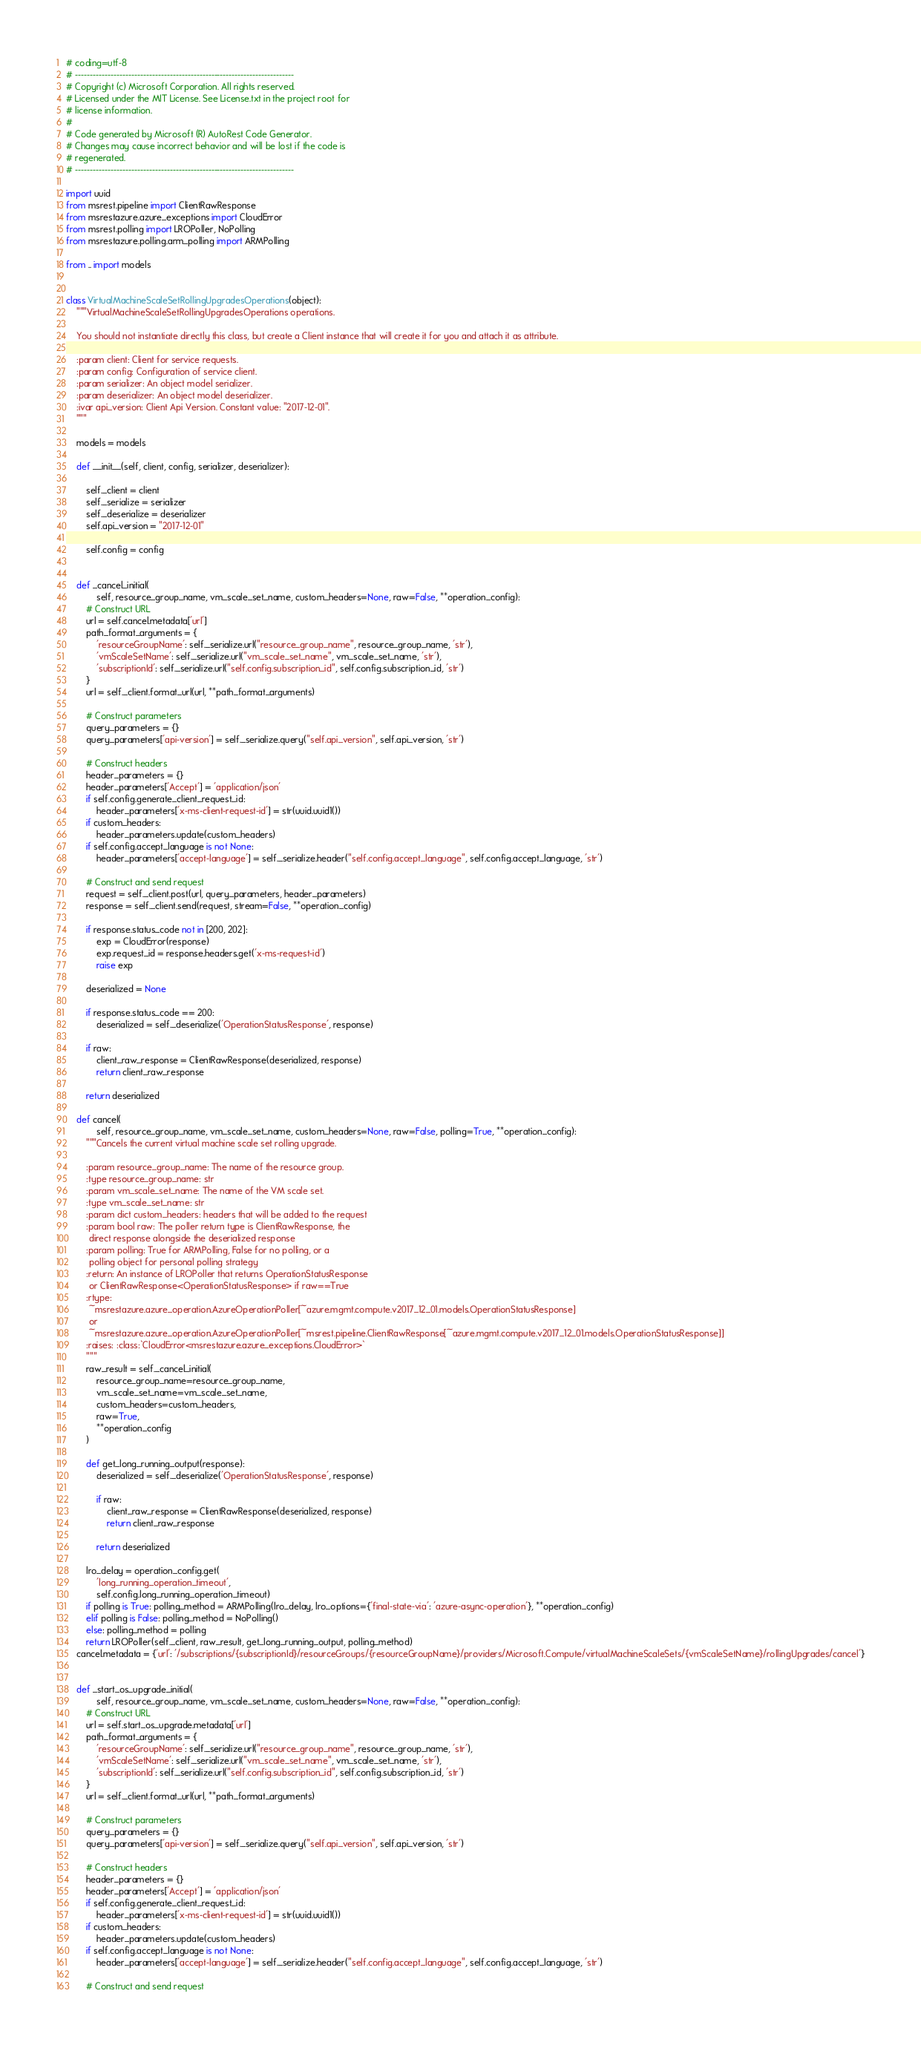<code> <loc_0><loc_0><loc_500><loc_500><_Python_># coding=utf-8
# --------------------------------------------------------------------------
# Copyright (c) Microsoft Corporation. All rights reserved.
# Licensed under the MIT License. See License.txt in the project root for
# license information.
#
# Code generated by Microsoft (R) AutoRest Code Generator.
# Changes may cause incorrect behavior and will be lost if the code is
# regenerated.
# --------------------------------------------------------------------------

import uuid
from msrest.pipeline import ClientRawResponse
from msrestazure.azure_exceptions import CloudError
from msrest.polling import LROPoller, NoPolling
from msrestazure.polling.arm_polling import ARMPolling

from .. import models


class VirtualMachineScaleSetRollingUpgradesOperations(object):
    """VirtualMachineScaleSetRollingUpgradesOperations operations.

    You should not instantiate directly this class, but create a Client instance that will create it for you and attach it as attribute.

    :param client: Client for service requests.
    :param config: Configuration of service client.
    :param serializer: An object model serializer.
    :param deserializer: An object model deserializer.
    :ivar api_version: Client Api Version. Constant value: "2017-12-01".
    """

    models = models

    def __init__(self, client, config, serializer, deserializer):

        self._client = client
        self._serialize = serializer
        self._deserialize = deserializer
        self.api_version = "2017-12-01"

        self.config = config


    def _cancel_initial(
            self, resource_group_name, vm_scale_set_name, custom_headers=None, raw=False, **operation_config):
        # Construct URL
        url = self.cancel.metadata['url']
        path_format_arguments = {
            'resourceGroupName': self._serialize.url("resource_group_name", resource_group_name, 'str'),
            'vmScaleSetName': self._serialize.url("vm_scale_set_name", vm_scale_set_name, 'str'),
            'subscriptionId': self._serialize.url("self.config.subscription_id", self.config.subscription_id, 'str')
        }
        url = self._client.format_url(url, **path_format_arguments)

        # Construct parameters
        query_parameters = {}
        query_parameters['api-version'] = self._serialize.query("self.api_version", self.api_version, 'str')

        # Construct headers
        header_parameters = {}
        header_parameters['Accept'] = 'application/json'
        if self.config.generate_client_request_id:
            header_parameters['x-ms-client-request-id'] = str(uuid.uuid1())
        if custom_headers:
            header_parameters.update(custom_headers)
        if self.config.accept_language is not None:
            header_parameters['accept-language'] = self._serialize.header("self.config.accept_language", self.config.accept_language, 'str')

        # Construct and send request
        request = self._client.post(url, query_parameters, header_parameters)
        response = self._client.send(request, stream=False, **operation_config)

        if response.status_code not in [200, 202]:
            exp = CloudError(response)
            exp.request_id = response.headers.get('x-ms-request-id')
            raise exp

        deserialized = None

        if response.status_code == 200:
            deserialized = self._deserialize('OperationStatusResponse', response)

        if raw:
            client_raw_response = ClientRawResponse(deserialized, response)
            return client_raw_response

        return deserialized

    def cancel(
            self, resource_group_name, vm_scale_set_name, custom_headers=None, raw=False, polling=True, **operation_config):
        """Cancels the current virtual machine scale set rolling upgrade.

        :param resource_group_name: The name of the resource group.
        :type resource_group_name: str
        :param vm_scale_set_name: The name of the VM scale set.
        :type vm_scale_set_name: str
        :param dict custom_headers: headers that will be added to the request
        :param bool raw: The poller return type is ClientRawResponse, the
         direct response alongside the deserialized response
        :param polling: True for ARMPolling, False for no polling, or a
         polling object for personal polling strategy
        :return: An instance of LROPoller that returns OperationStatusResponse
         or ClientRawResponse<OperationStatusResponse> if raw==True
        :rtype:
         ~msrestazure.azure_operation.AzureOperationPoller[~azure.mgmt.compute.v2017_12_01.models.OperationStatusResponse]
         or
         ~msrestazure.azure_operation.AzureOperationPoller[~msrest.pipeline.ClientRawResponse[~azure.mgmt.compute.v2017_12_01.models.OperationStatusResponse]]
        :raises: :class:`CloudError<msrestazure.azure_exceptions.CloudError>`
        """
        raw_result = self._cancel_initial(
            resource_group_name=resource_group_name,
            vm_scale_set_name=vm_scale_set_name,
            custom_headers=custom_headers,
            raw=True,
            **operation_config
        )

        def get_long_running_output(response):
            deserialized = self._deserialize('OperationStatusResponse', response)

            if raw:
                client_raw_response = ClientRawResponse(deserialized, response)
                return client_raw_response

            return deserialized

        lro_delay = operation_config.get(
            'long_running_operation_timeout',
            self.config.long_running_operation_timeout)
        if polling is True: polling_method = ARMPolling(lro_delay, lro_options={'final-state-via': 'azure-async-operation'}, **operation_config)
        elif polling is False: polling_method = NoPolling()
        else: polling_method = polling
        return LROPoller(self._client, raw_result, get_long_running_output, polling_method)
    cancel.metadata = {'url': '/subscriptions/{subscriptionId}/resourceGroups/{resourceGroupName}/providers/Microsoft.Compute/virtualMachineScaleSets/{vmScaleSetName}/rollingUpgrades/cancel'}


    def _start_os_upgrade_initial(
            self, resource_group_name, vm_scale_set_name, custom_headers=None, raw=False, **operation_config):
        # Construct URL
        url = self.start_os_upgrade.metadata['url']
        path_format_arguments = {
            'resourceGroupName': self._serialize.url("resource_group_name", resource_group_name, 'str'),
            'vmScaleSetName': self._serialize.url("vm_scale_set_name", vm_scale_set_name, 'str'),
            'subscriptionId': self._serialize.url("self.config.subscription_id", self.config.subscription_id, 'str')
        }
        url = self._client.format_url(url, **path_format_arguments)

        # Construct parameters
        query_parameters = {}
        query_parameters['api-version'] = self._serialize.query("self.api_version", self.api_version, 'str')

        # Construct headers
        header_parameters = {}
        header_parameters['Accept'] = 'application/json'
        if self.config.generate_client_request_id:
            header_parameters['x-ms-client-request-id'] = str(uuid.uuid1())
        if custom_headers:
            header_parameters.update(custom_headers)
        if self.config.accept_language is not None:
            header_parameters['accept-language'] = self._serialize.header("self.config.accept_language", self.config.accept_language, 'str')

        # Construct and send request</code> 